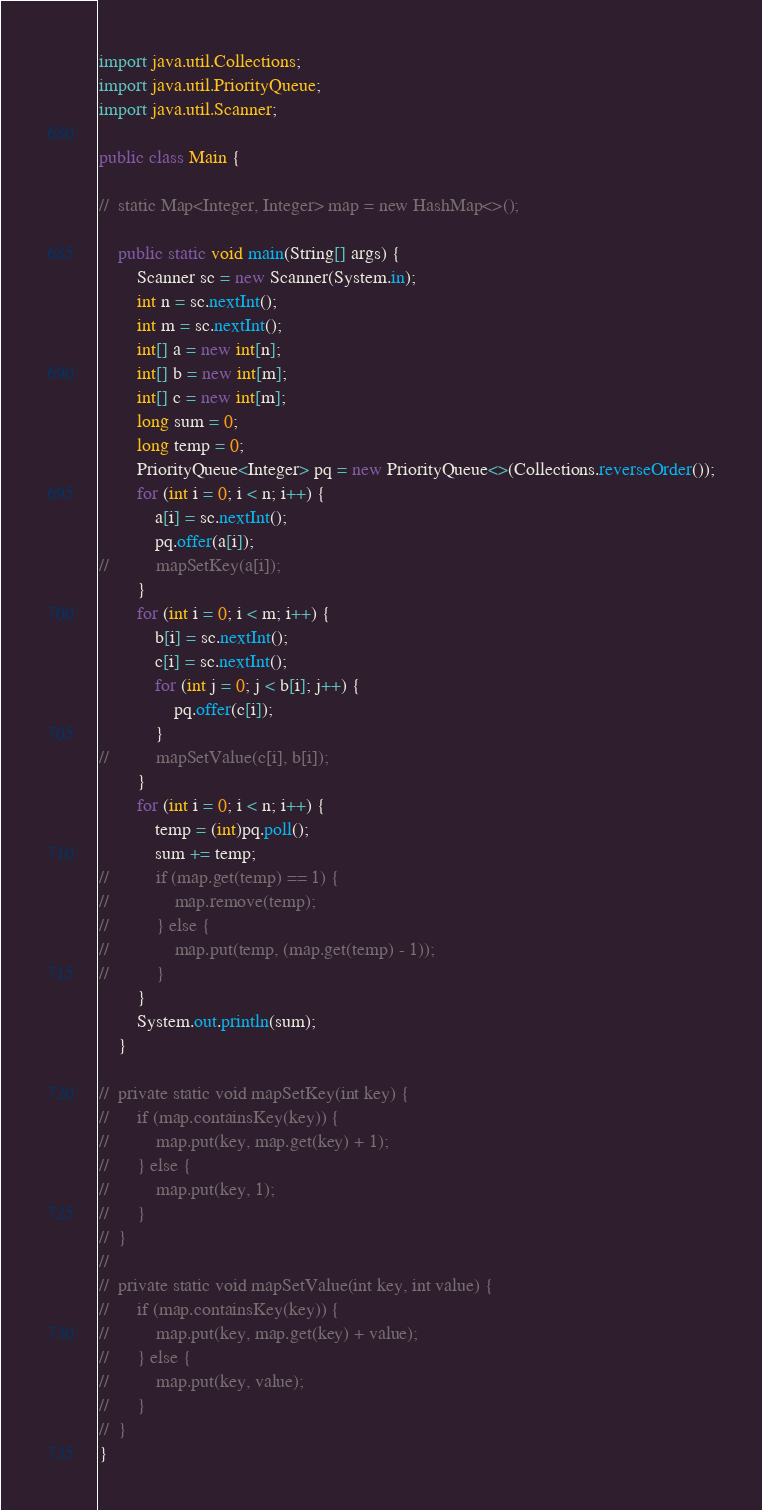<code> <loc_0><loc_0><loc_500><loc_500><_Java_>import java.util.Collections;
import java.util.PriorityQueue;
import java.util.Scanner;

public class Main {

//	static Map<Integer, Integer> map = new HashMap<>();

	public static void main(String[] args) {
		Scanner sc = new Scanner(System.in);
		int n = sc.nextInt();
		int m = sc.nextInt();
		int[] a = new int[n];
		int[] b = new int[m];
		int[] c = new int[m];
		long sum = 0;
		long temp = 0;
		PriorityQueue<Integer> pq = new PriorityQueue<>(Collections.reverseOrder());
		for (int i = 0; i < n; i++) {
			a[i] = sc.nextInt();
			pq.offer(a[i]);
//			mapSetKey(a[i]);
		}
		for (int i = 0; i < m; i++) {
			b[i] = sc.nextInt();
			c[i] = sc.nextInt();
			for (int j = 0; j < b[i]; j++) {
				pq.offer(c[i]);
			}
//			mapSetValue(c[i], b[i]);
		}
		for (int i = 0; i < n; i++) {
			temp = (int)pq.poll();
			sum += temp;
//			if (map.get(temp) == 1) {
//				map.remove(temp);
//			} else {
//				map.put(temp, (map.get(temp) - 1));
//			}
		}
		System.out.println(sum);
	}

//	private static void mapSetKey(int key) {
//		if (map.containsKey(key)) {
//			map.put(key, map.get(key) + 1);
//		} else {
//			map.put(key, 1);
//		}
//	}
//
//	private static void mapSetValue(int key, int value) {
//		if (map.containsKey(key)) {
//			map.put(key, map.get(key) + value);
//		} else {
//			map.put(key, value);
//		}
//	}
}</code> 